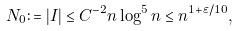<formula> <loc_0><loc_0><loc_500><loc_500>N _ { 0 } \colon = | I | \leq C ^ { - 2 } n \log ^ { 5 } n \leq n ^ { 1 + \varepsilon / 1 0 } ,</formula> 